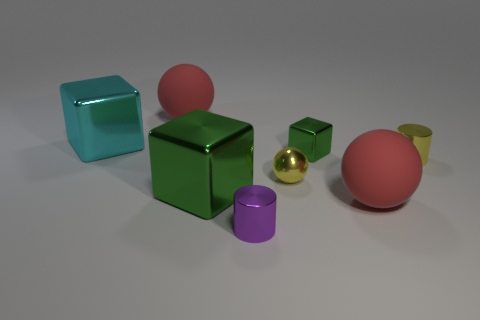What number of other things are there of the same color as the shiny ball?
Offer a very short reply. 1. Is the color of the small block the same as the big metallic block that is in front of the small green metal cube?
Provide a short and direct response. Yes. Is the shape of the tiny green metallic thing the same as the large cyan metallic object?
Keep it short and to the point. Yes. What number of balls are either cyan metal objects or tiny yellow things?
Offer a terse response. 1. There is a tiny ball that is made of the same material as the big green thing; what color is it?
Your answer should be compact. Yellow. Does the object behind the cyan block have the same size as the cyan metallic object?
Provide a short and direct response. Yes. Is the material of the purple cylinder the same as the big ball to the left of the tiny block?
Provide a succinct answer. No. The big matte object that is in front of the small yellow shiny ball is what color?
Keep it short and to the point. Red. Is there a tiny ball behind the yellow object that is behind the yellow shiny sphere?
Provide a short and direct response. No. There is a large sphere behind the small shiny cube; is it the same color as the big rubber ball in front of the tiny metal block?
Keep it short and to the point. Yes. 